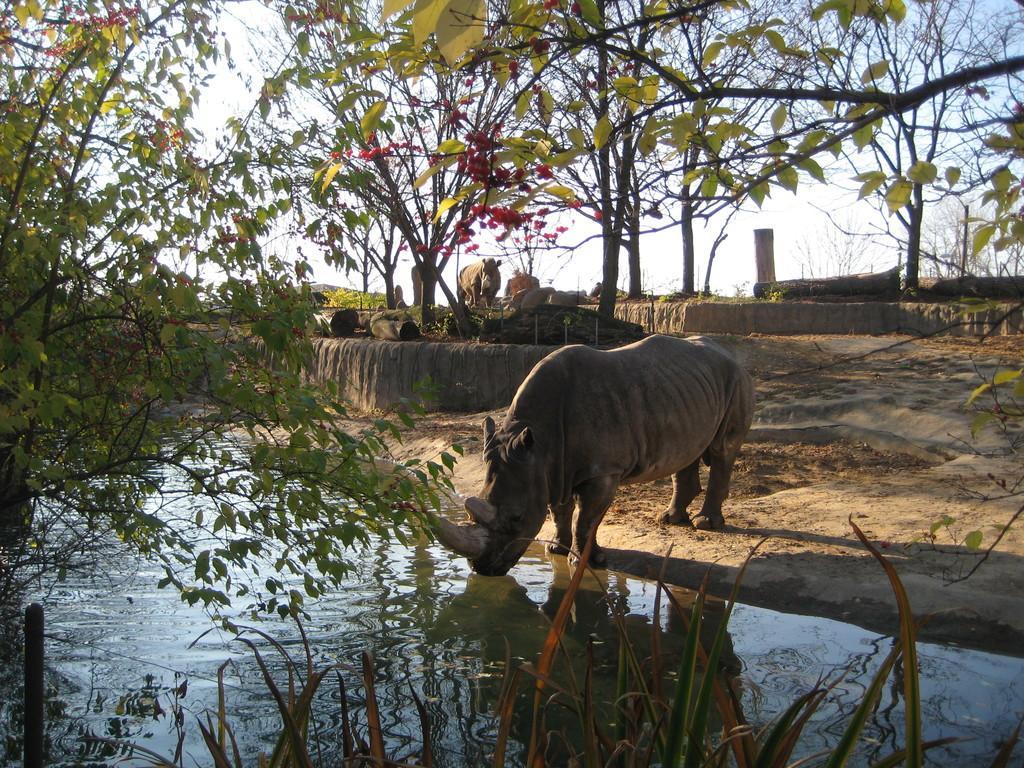Can you describe this image briefly? In this image I can see an animal and the animal is drinking water, background I can see the other animal, trees in green color and the sky is in white color. 